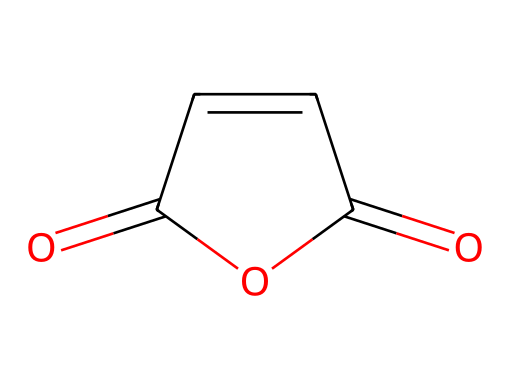What is the molecular formula of maleic anhydride? To determine the molecular formula, count the number of carbon (C), oxygen (O), and hydrogen (H) atoms in the structure. The structure consists of 4 carbon atoms, 2 oxygen atoms, and 2 hydrogen atoms, giving the formula C4H2O3.
Answer: C4H2O3 How many double bonds are present in the structure? In the provided structure, count the number of double bonds: there are 3 double bonds (one between carbons, one between carbon and oxygen in the anhydride form, and the other also between carbon and oxygen).
Answer: 3 What type of chemical is maleic anhydride? Maleic anhydride is classified as an acid anhydride due to its ability to form acids upon hydrolysis.
Answer: acid anhydride What functional groups are present in maleic anhydride? Analyzing the structure reveals that it contains both anhydride and alkene functional groups. The presence of both indicates its classification as an anhydride.
Answer: anhydride, alkene How many resonance structures can maleic anhydride have? By drawing the resonance structures, we can observe that maleic anhydride can have 2 significant resonance forms due to the delocalization of electrons in the double bonds.
Answer: 2 What is the effect of maleic anhydride on soil pH? Maleic anhydride tends to contribute to a lower soil pH due to its acidic nature when it interacts in soil conditions.
Answer: lower soil pH What is the boiling point of maleic anhydride? The boiling point of maleic anhydride is approximately 202 degrees Celsius, based on its chemical properties and structure context.
Answer: 202 degrees Celsius 